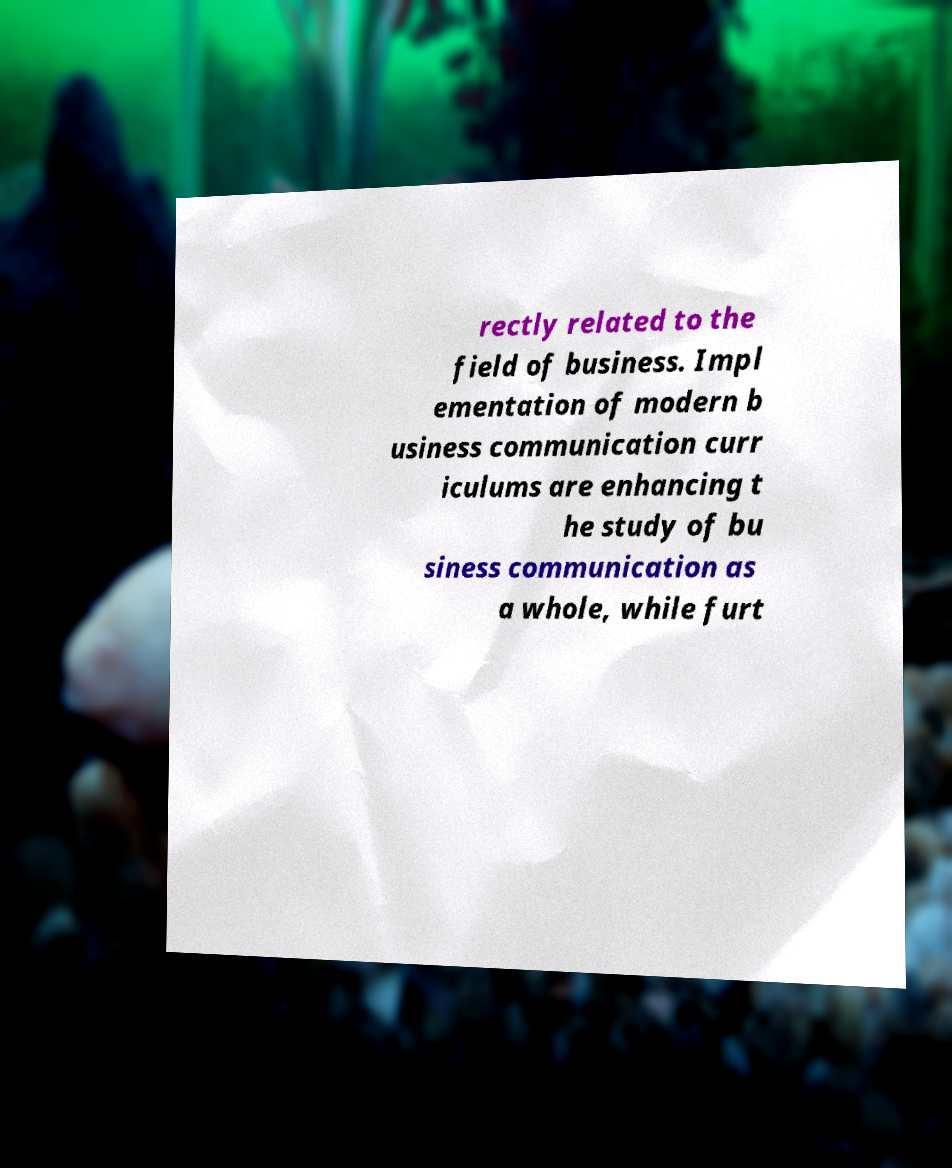For documentation purposes, I need the text within this image transcribed. Could you provide that? rectly related to the field of business. Impl ementation of modern b usiness communication curr iculums are enhancing t he study of bu siness communication as a whole, while furt 